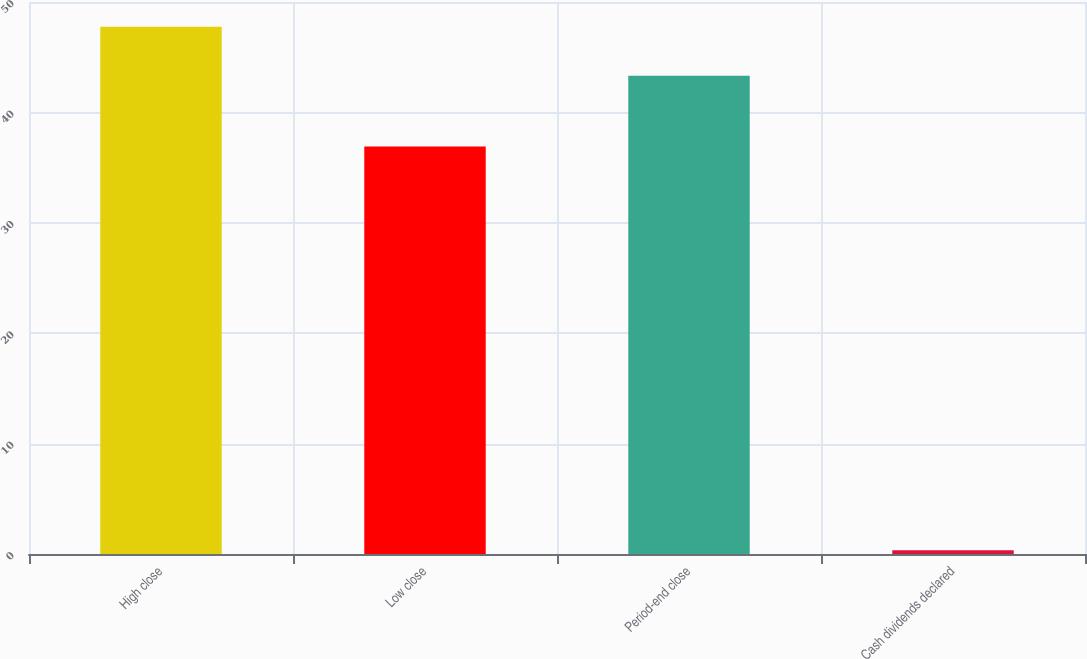Convert chart. <chart><loc_0><loc_0><loc_500><loc_500><bar_chart><fcel>High close<fcel>Low close<fcel>Period-end close<fcel>Cash dividends declared<nl><fcel>47.75<fcel>36.91<fcel>43.31<fcel>0.35<nl></chart> 